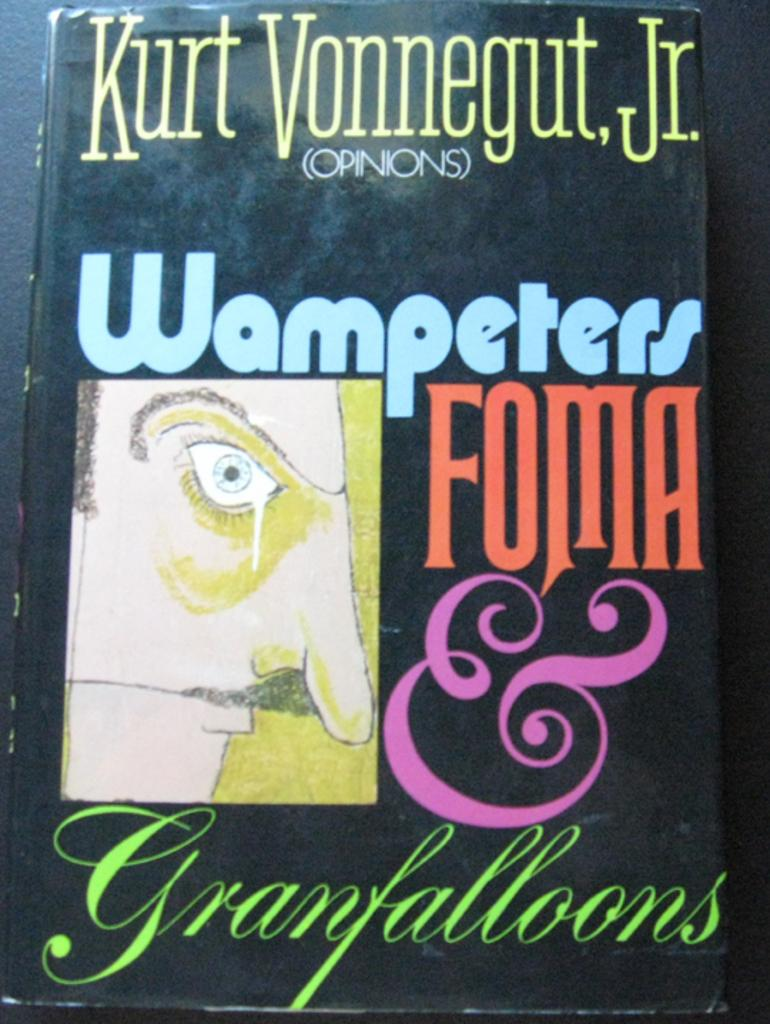What object is present in the image? There is a book in the image. What is depicted on the book? The book has a picture of a person's face on it. What else can be seen on the book? Text is written on the book. Can you tell me how many airports are visible in the image? There are no airports present in the image; it features a book with a person's face and text. What type of root is growing out of the book in the image? There is no root growing out of the book in the image; it is a book with a picture and text. 